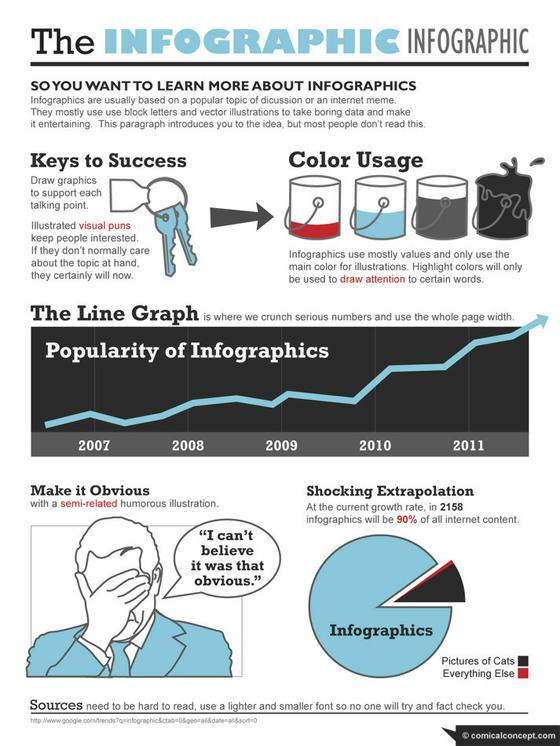Outline some significant characteristics in this image. By 2158, as much as 10% of internet content may be missing due to the current growth rate of infographics. In 2010, infographics gained widespread recognition and popularity after years of fluctuation in their use. Infographics primarily rely on values and limit the use of color to key illustrations. 